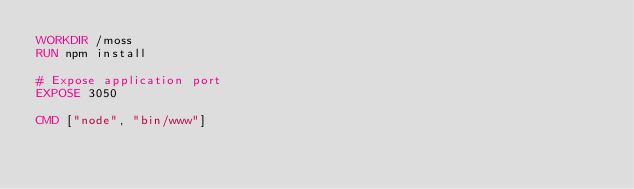Convert code to text. <code><loc_0><loc_0><loc_500><loc_500><_Dockerfile_>WORKDIR /moss
RUN npm install

# Expose application port
EXPOSE 3050

CMD ["node", "bin/www"]</code> 